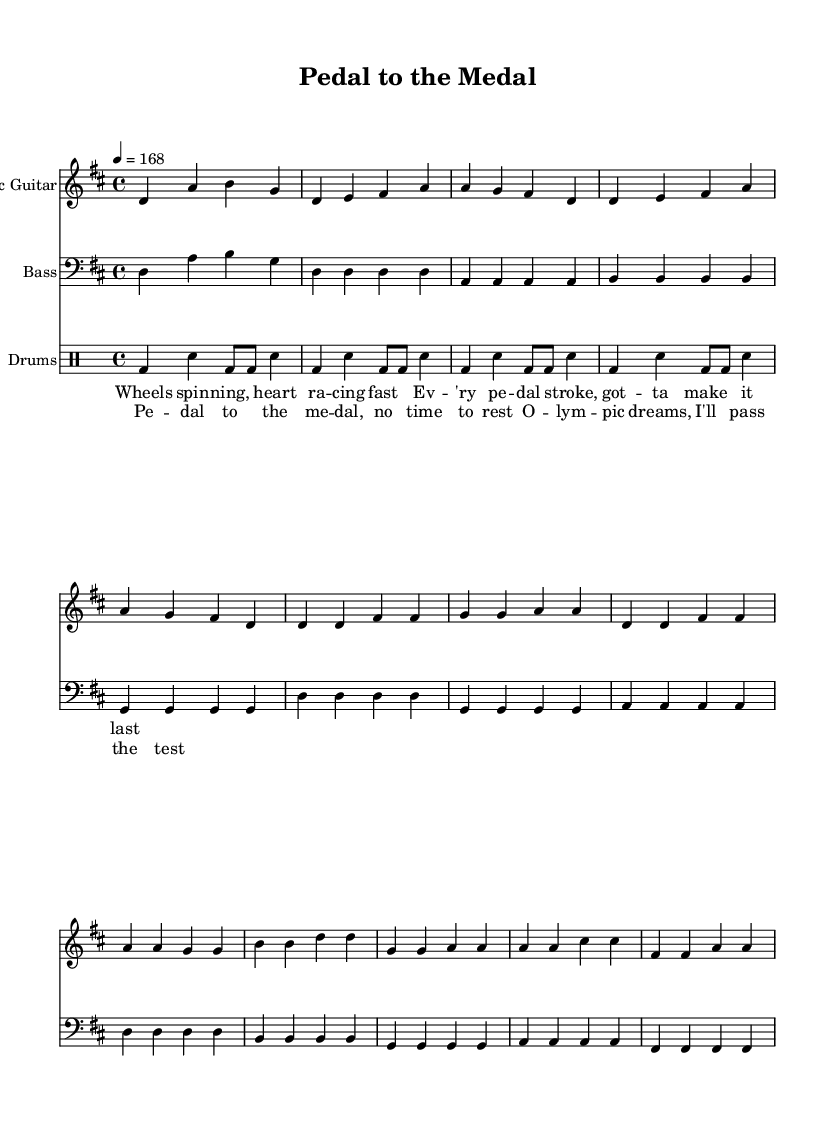What is the key signature of this music? The key signature is indicated by the presence of two sharps (F# and C#), which is typical for D major.
Answer: D major What is the time signature of this piece? The time signature, shown at the start of the sheet music, is 4/4, indicating four beats per measure.
Answer: 4/4 What is the tempo marking for this composition? The tempo marking is indicated by the note value and a metronome marking of 168 beats per minute, which suggests a fast-paced rhythm suitable for punk music.
Answer: 168 What instruments are used in this piece? The instruments are specified at the beginning of each staff: Electric Guitar, Bass, and Drums. Together, they provide the typical instrumentation for a punk rock band.
Answer: Electric Guitar, Bass, Drums How many measures does the chorus section contain? By counting the measures in the chorus section, which is distinctly separated, it totals to four measures.
Answer: Four measures What type of rhythm is primarily used in the drum part? In the drum part, the primary rhythm is a standard punk beat characterized by bass drums and snare hits, which provides a steady driving force throughout the music.
Answer: Punk beat What lyrical theme is expressed in the chorus? The chorus conveys themes of determination and ambition, with the lyrics emphasizing the drive towards Olympic dreams. This reflects the overall motivational aspect of the song aimed at overcoming obstacles.
Answer: Motivation and ambition 